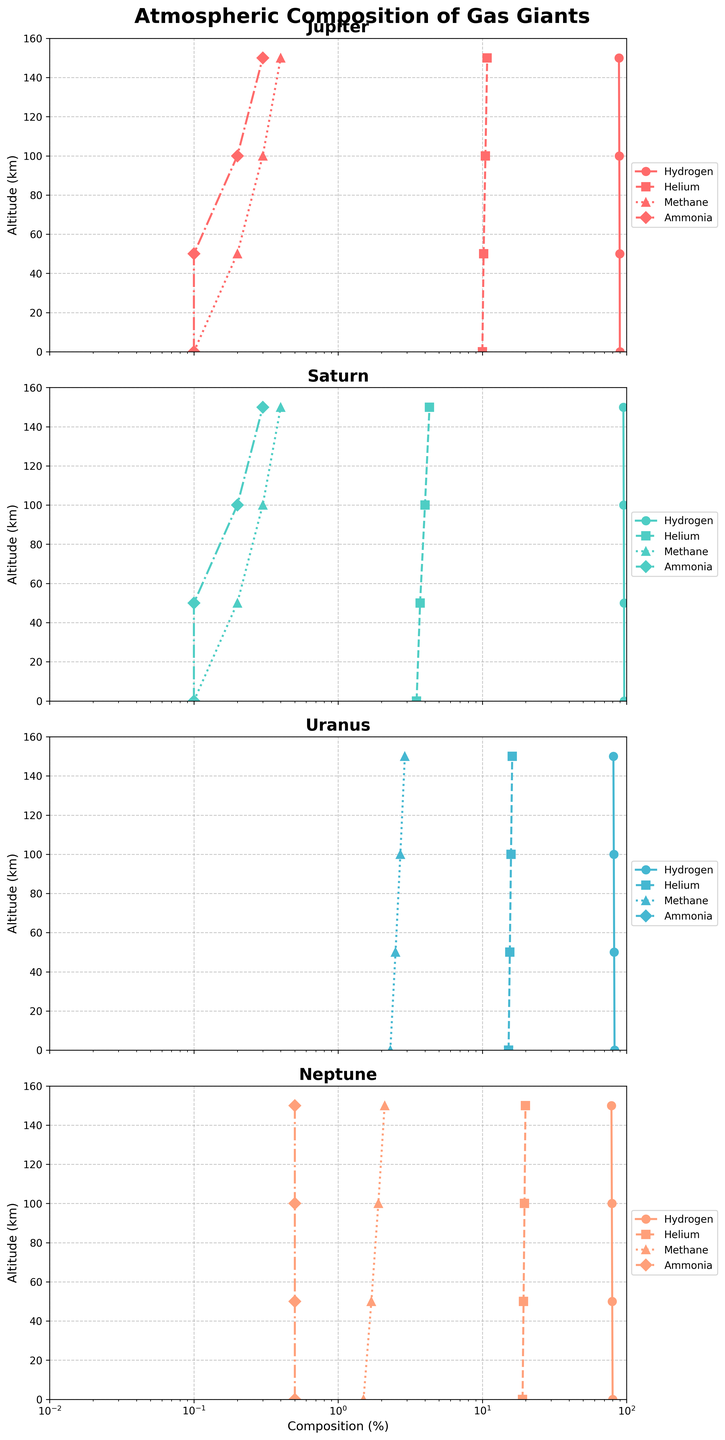What is the main title of the figure? The title is located at the top of the figure and summarizes the content depicted in the subplots. The main title is "Atmospheric Composition of Gas Giants."
Answer: Atmospheric Composition of Gas Giants What's the highest altitude shown for each planet? The y-axis of each subplot represents altitude in kilometers, ending at 150 km, as indicated by the axis limits and tick marks.
Answer: 150 km Which gas has the highest percentage in Saturn's atmosphere at 0 km? The subplots show the composition of gases across varying altitudes. In Saturn's subplot, at 0 km, the percentage of Hydrogen is the highest, as indicated by the plot lines.
Answer: Hydrogen How does the percentage of Helium change with altitude on Uranus? Observing Uranus's subplot, the line representing Helium shows an upward trend from 15.2% at 0 km to 16.1% at 150 km.
Answer: Increases Which planet has the most significant variation in methane percentage with altitude? By comparing the methane percentage lines across all subplots, Neptune shows the most consistent increase from 1.5% to 2.1% over the altitude range, indicating the most significant change among the planets.
Answer: Neptune What is the difference in Hydrogen percentage between the altitudes of 0 km and 150 km on Jupiter? For Jupiter's subplot, observe the Hydrogen line; at 0 km it is 89.8% and at 150 km, it is 88.5%. The difference is 89.8% - 88.5% = 1.3%.
Answer: 1.3% Which gas remains constant in percentage at different altitudes on Uranus? Observing the subplot for Uranus, the Ammonia percentage remains at 0% consistently across all altitudes.
Answer: Ammonia Compare the percentage of Methane at 100 km for Jupiter and Saturn. In the subplots for Jupiter and Saturn, the lines for Methane are at approximately 0.3% for Jupiter and 0.3% for Saturn at an altitude of 100 km. Both values are equal.
Answer: Equal If we look at Neptune's atmosphere, which gas shows no variation with altitude? Examining Neptune's subplot, the Ammonia line remains flat at 0.5% across all altitudes, indicating no variation.
Answer: Ammonia What pattern can we observe in the Helium percentage for Saturn as altitude increases? Saturn's subplot shows a Helium line starting from 3.5% at 0 km and gradually increasing to 4.3% at 150 km, indicating a consistently upward trend.
Answer: Increasing 